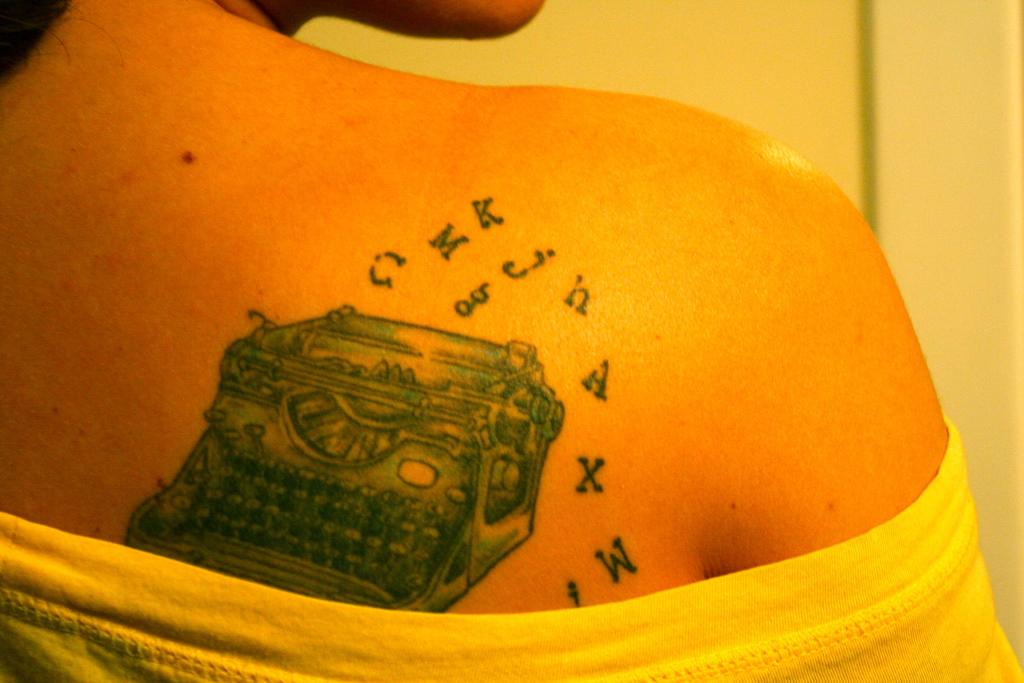What is present in the image? There is a person in the image. Can you describe any distinguishing features of the person? The person has a tattoo. What can be seen in the background of the image? There is a wall in the background of the image. How does the person interact with the friction in the image? There is no mention of friction in the image, so it cannot be determined how the person interacts with it. 